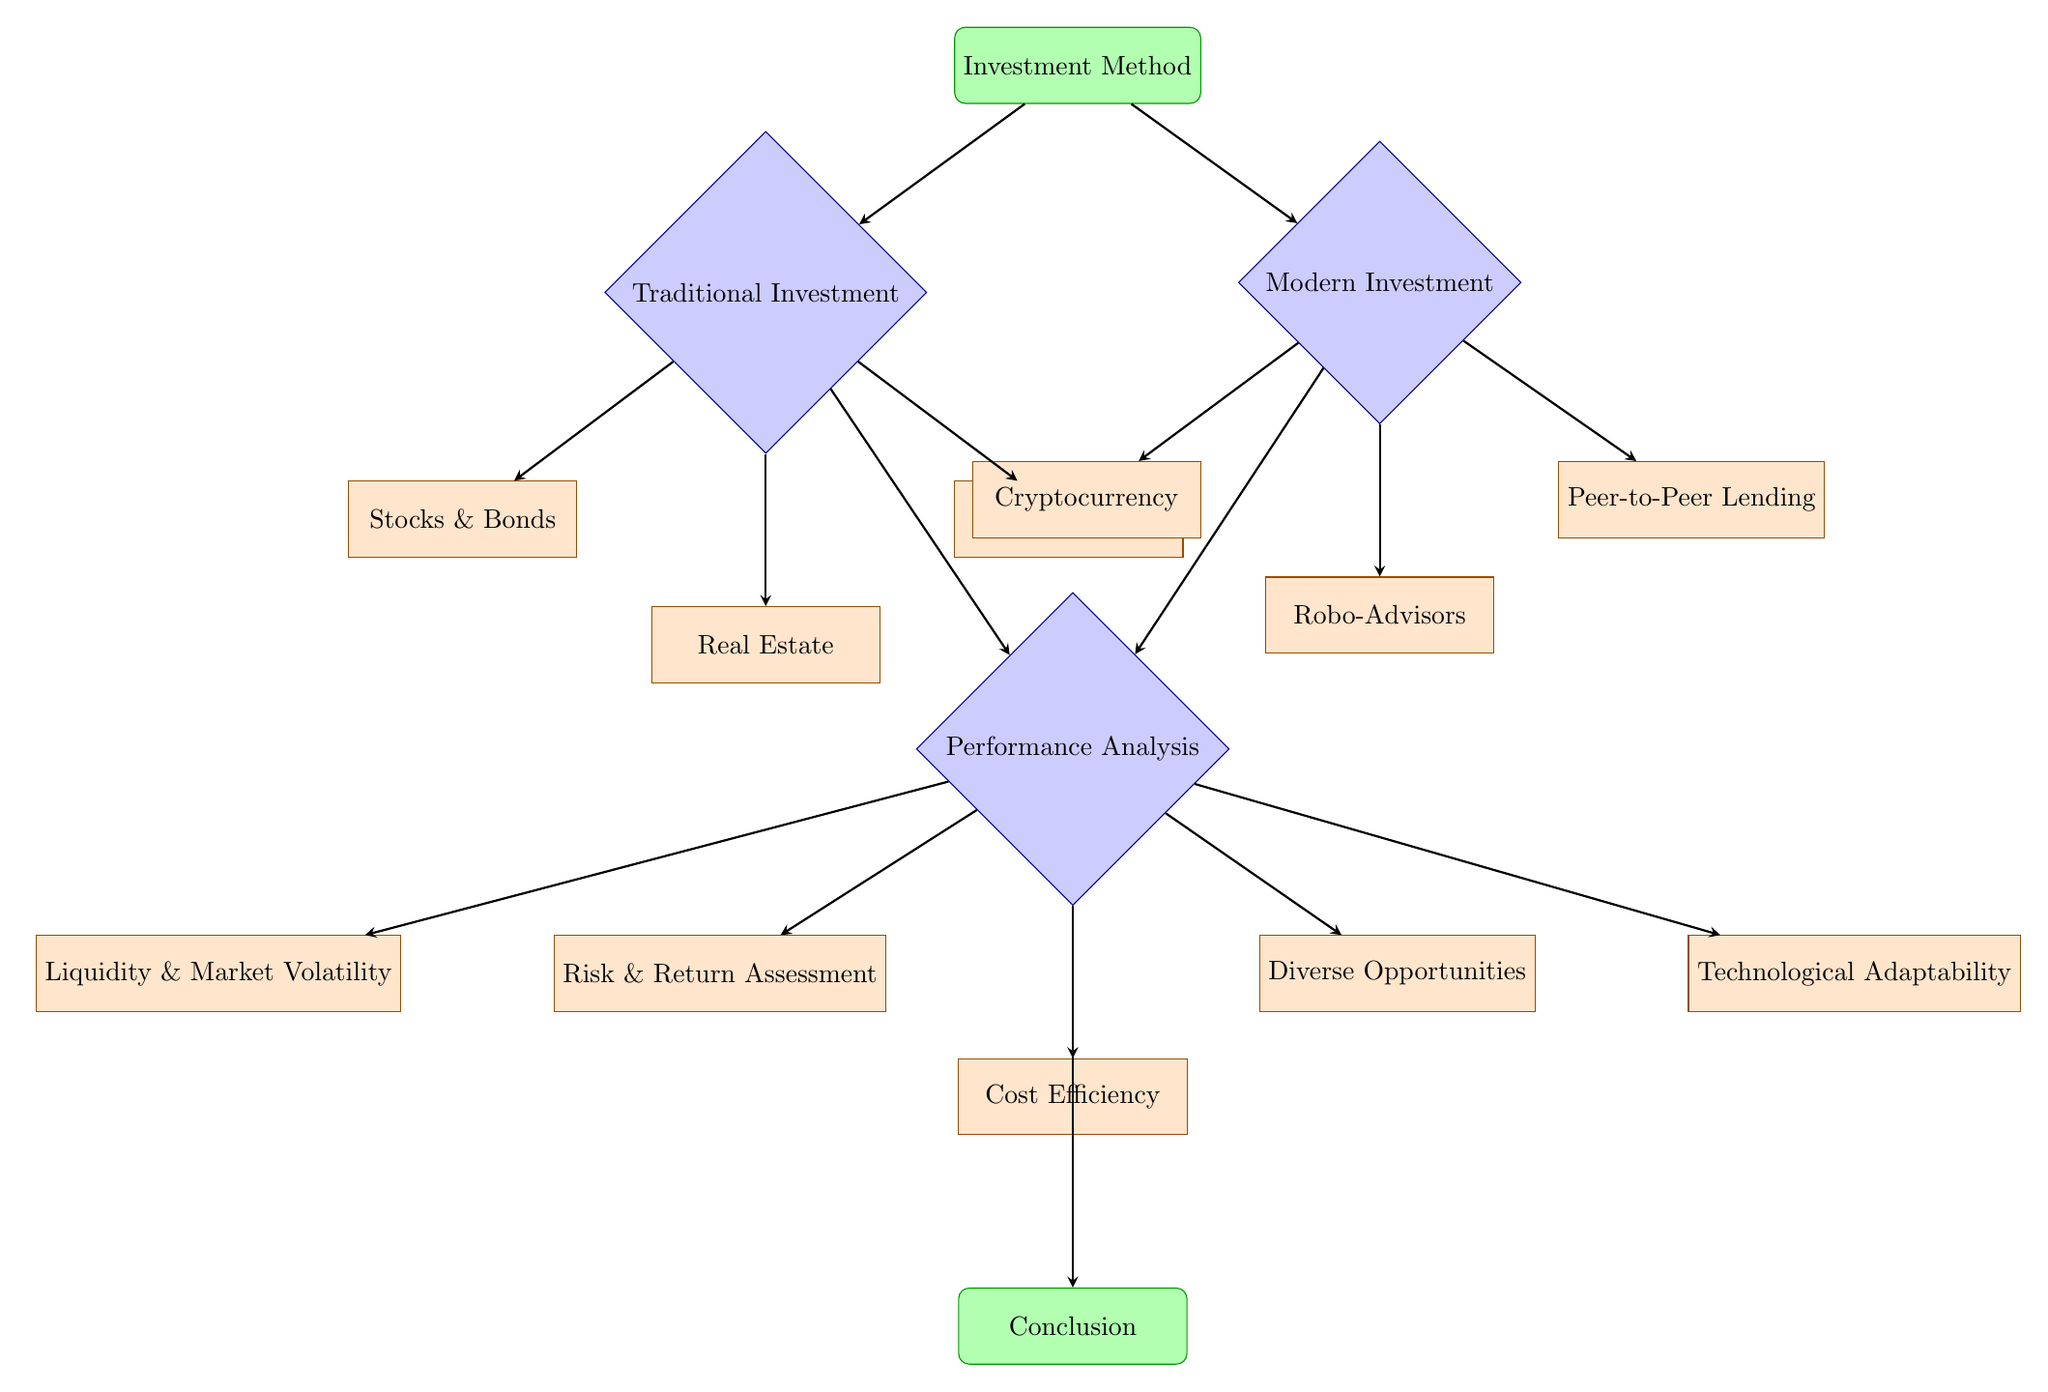What are the two main categories of investment methods in the diagram? The diagram branches into two main categories after the initial node: Traditional Investment and Modern Investment.
Answer: Traditional Investment, Modern Investment How many traditional investment types are listed in the diagram? The diagram indicates three types of traditional investments: Stocks & Bonds, Real Estate, and Mutual Funds.
Answer: 3 What types of modern investments are represented in the diagram? The modern investments represented are Cryptocurrency, Robo-Advisors, and Peer-to-Peer Lending, which can be identified directly from the corresponding nodes under Modern Investment.
Answer: Cryptocurrency, Robo-Advisors, Peer-to-Peer Lending Which decision node comes after the investment methods node? The first decision node encountered after the investment methods node is the Performance Analysis node, which leads to subsequent assessment processes.
Answer: Performance Analysis What processes follow the performance analysis decision node for traditional investments? The processes that follow for traditional investments are Risk & Return Assessment and Liquidity & Market Volatility, as shown by their direct connections to the Performance Analysis node.
Answer: Risk & Return Assessment, Liquidity & Market Volatility What is the last process linked to the conclusion node? The last process linked to the conclusion node is Cost Efficiency, which is connected directly from Performance Analysis before reaching the Conclusion node.
Answer: Cost Efficiency Which investment category has a process related to diverse opportunities? The Modern Investment category has a process related to Diverse Opportunities, indicating its potential for varied investment options compared to traditional methods.
Answer: Modern Investment 